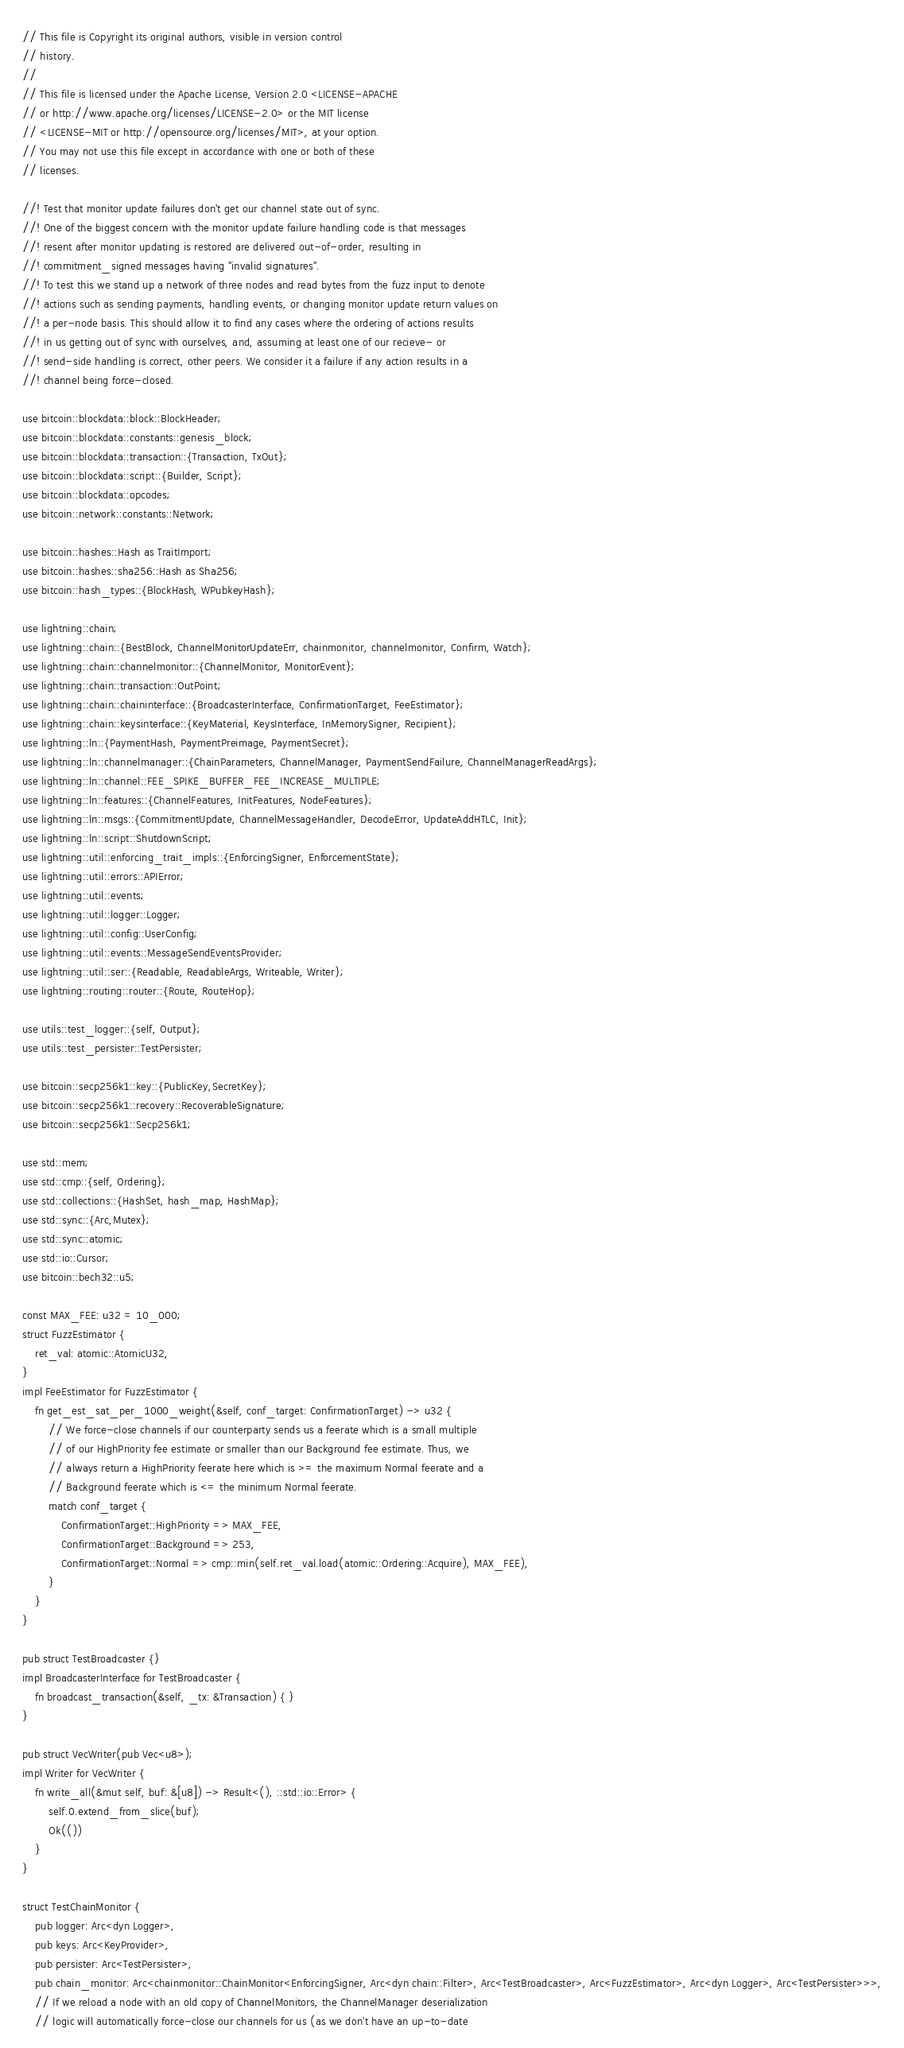<code> <loc_0><loc_0><loc_500><loc_500><_Rust_>// This file is Copyright its original authors, visible in version control
// history.
//
// This file is licensed under the Apache License, Version 2.0 <LICENSE-APACHE
// or http://www.apache.org/licenses/LICENSE-2.0> or the MIT license
// <LICENSE-MIT or http://opensource.org/licenses/MIT>, at your option.
// You may not use this file except in accordance with one or both of these
// licenses.

//! Test that monitor update failures don't get our channel state out of sync.
//! One of the biggest concern with the monitor update failure handling code is that messages
//! resent after monitor updating is restored are delivered out-of-order, resulting in
//! commitment_signed messages having "invalid signatures".
//! To test this we stand up a network of three nodes and read bytes from the fuzz input to denote
//! actions such as sending payments, handling events, or changing monitor update return values on
//! a per-node basis. This should allow it to find any cases where the ordering of actions results
//! in us getting out of sync with ourselves, and, assuming at least one of our recieve- or
//! send-side handling is correct, other peers. We consider it a failure if any action results in a
//! channel being force-closed.

use bitcoin::blockdata::block::BlockHeader;
use bitcoin::blockdata::constants::genesis_block;
use bitcoin::blockdata::transaction::{Transaction, TxOut};
use bitcoin::blockdata::script::{Builder, Script};
use bitcoin::blockdata::opcodes;
use bitcoin::network::constants::Network;

use bitcoin::hashes::Hash as TraitImport;
use bitcoin::hashes::sha256::Hash as Sha256;
use bitcoin::hash_types::{BlockHash, WPubkeyHash};

use lightning::chain;
use lightning::chain::{BestBlock, ChannelMonitorUpdateErr, chainmonitor, channelmonitor, Confirm, Watch};
use lightning::chain::channelmonitor::{ChannelMonitor, MonitorEvent};
use lightning::chain::transaction::OutPoint;
use lightning::chain::chaininterface::{BroadcasterInterface, ConfirmationTarget, FeeEstimator};
use lightning::chain::keysinterface::{KeyMaterial, KeysInterface, InMemorySigner, Recipient};
use lightning::ln::{PaymentHash, PaymentPreimage, PaymentSecret};
use lightning::ln::channelmanager::{ChainParameters, ChannelManager, PaymentSendFailure, ChannelManagerReadArgs};
use lightning::ln::channel::FEE_SPIKE_BUFFER_FEE_INCREASE_MULTIPLE;
use lightning::ln::features::{ChannelFeatures, InitFeatures, NodeFeatures};
use lightning::ln::msgs::{CommitmentUpdate, ChannelMessageHandler, DecodeError, UpdateAddHTLC, Init};
use lightning::ln::script::ShutdownScript;
use lightning::util::enforcing_trait_impls::{EnforcingSigner, EnforcementState};
use lightning::util::errors::APIError;
use lightning::util::events;
use lightning::util::logger::Logger;
use lightning::util::config::UserConfig;
use lightning::util::events::MessageSendEventsProvider;
use lightning::util::ser::{Readable, ReadableArgs, Writeable, Writer};
use lightning::routing::router::{Route, RouteHop};

use utils::test_logger::{self, Output};
use utils::test_persister::TestPersister;

use bitcoin::secp256k1::key::{PublicKey,SecretKey};
use bitcoin::secp256k1::recovery::RecoverableSignature;
use bitcoin::secp256k1::Secp256k1;

use std::mem;
use std::cmp::{self, Ordering};
use std::collections::{HashSet, hash_map, HashMap};
use std::sync::{Arc,Mutex};
use std::sync::atomic;
use std::io::Cursor;
use bitcoin::bech32::u5;

const MAX_FEE: u32 = 10_000;
struct FuzzEstimator {
	ret_val: atomic::AtomicU32,
}
impl FeeEstimator for FuzzEstimator {
	fn get_est_sat_per_1000_weight(&self, conf_target: ConfirmationTarget) -> u32 {
		// We force-close channels if our counterparty sends us a feerate which is a small multiple
		// of our HighPriority fee estimate or smaller than our Background fee estimate. Thus, we
		// always return a HighPriority feerate here which is >= the maximum Normal feerate and a
		// Background feerate which is <= the minimum Normal feerate.
		match conf_target {
			ConfirmationTarget::HighPriority => MAX_FEE,
			ConfirmationTarget::Background => 253,
			ConfirmationTarget::Normal => cmp::min(self.ret_val.load(atomic::Ordering::Acquire), MAX_FEE),
		}
	}
}

pub struct TestBroadcaster {}
impl BroadcasterInterface for TestBroadcaster {
	fn broadcast_transaction(&self, _tx: &Transaction) { }
}

pub struct VecWriter(pub Vec<u8>);
impl Writer for VecWriter {
	fn write_all(&mut self, buf: &[u8]) -> Result<(), ::std::io::Error> {
		self.0.extend_from_slice(buf);
		Ok(())
	}
}

struct TestChainMonitor {
	pub logger: Arc<dyn Logger>,
	pub keys: Arc<KeyProvider>,
	pub persister: Arc<TestPersister>,
	pub chain_monitor: Arc<chainmonitor::ChainMonitor<EnforcingSigner, Arc<dyn chain::Filter>, Arc<TestBroadcaster>, Arc<FuzzEstimator>, Arc<dyn Logger>, Arc<TestPersister>>>,
	// If we reload a node with an old copy of ChannelMonitors, the ChannelManager deserialization
	// logic will automatically force-close our channels for us (as we don't have an up-to-date</code> 